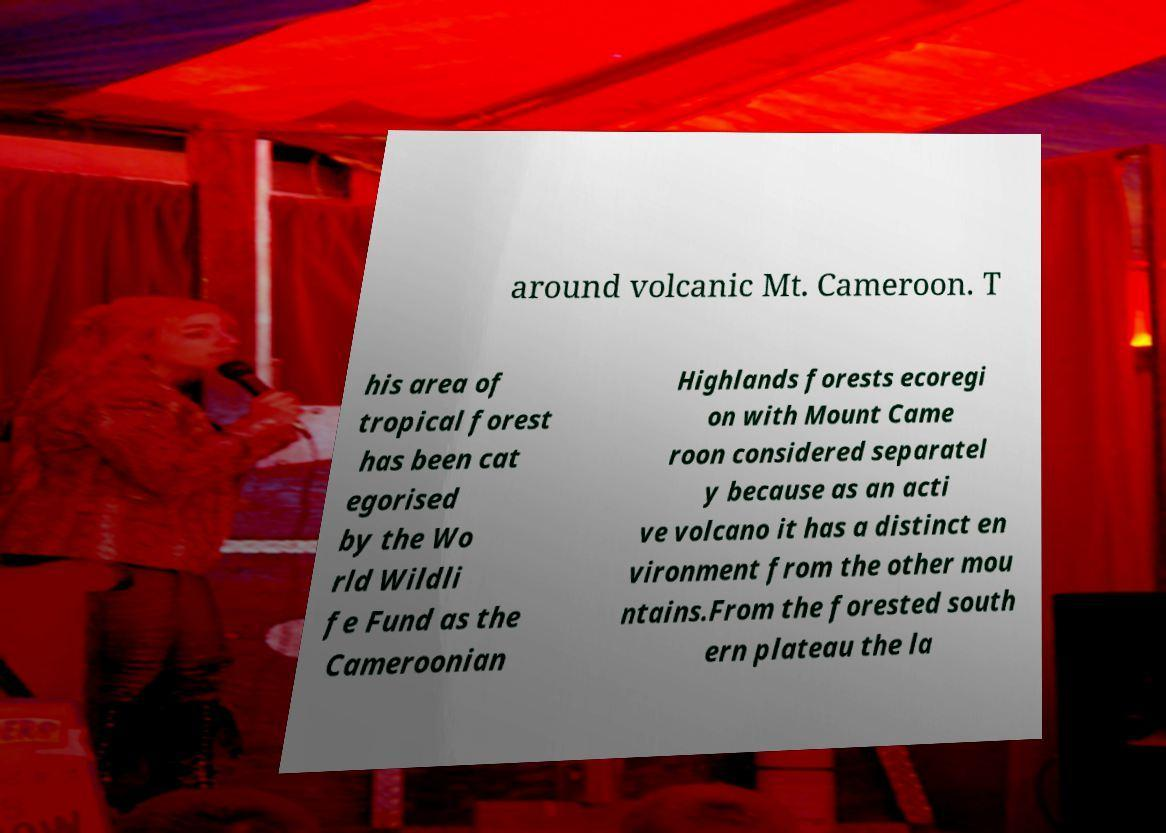Please identify and transcribe the text found in this image. around volcanic Mt. Cameroon. T his area of tropical forest has been cat egorised by the Wo rld Wildli fe Fund as the Cameroonian Highlands forests ecoregi on with Mount Came roon considered separatel y because as an acti ve volcano it has a distinct en vironment from the other mou ntains.From the forested south ern plateau the la 